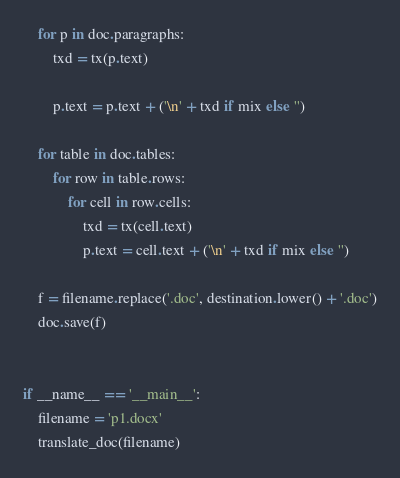Convert code to text. <code><loc_0><loc_0><loc_500><loc_500><_Python_>    for p in doc.paragraphs:
        txd = tx(p.text)

        p.text = p.text + ('\n' + txd if mix else '')

    for table in doc.tables:
        for row in table.rows:
            for cell in row.cells:
                txd = tx(cell.text)
                p.text = cell.text + ('\n' + txd if mix else '')

    f = filename.replace('.doc', destination.lower() + '.doc')
    doc.save(f)


if __name__ == '__main__':
    filename = 'p1.docx'
    translate_doc(filename)
</code> 